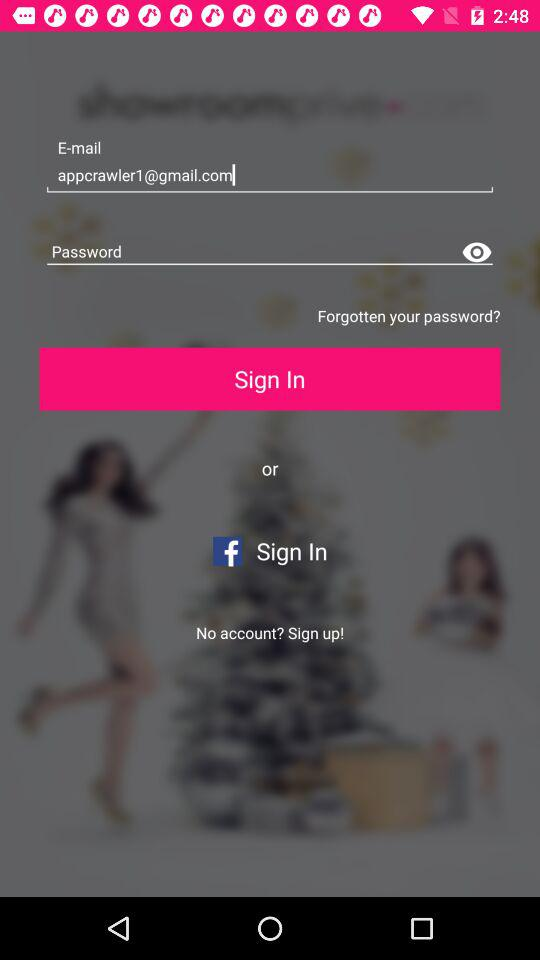What is the email address? The email address is appcrawler1@gmail.com. 